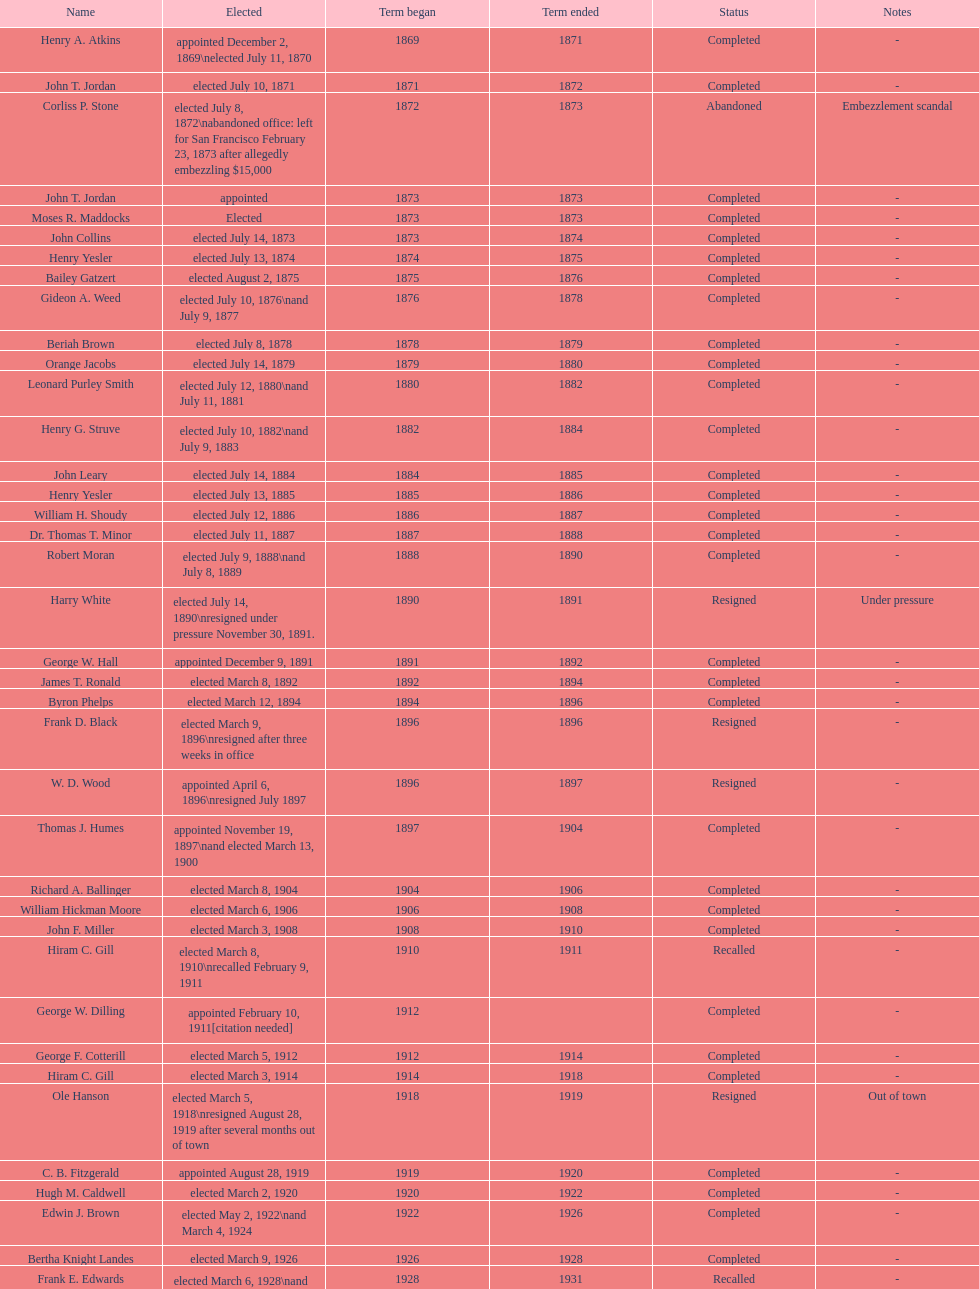Who began their term in 1890? Harry White. 